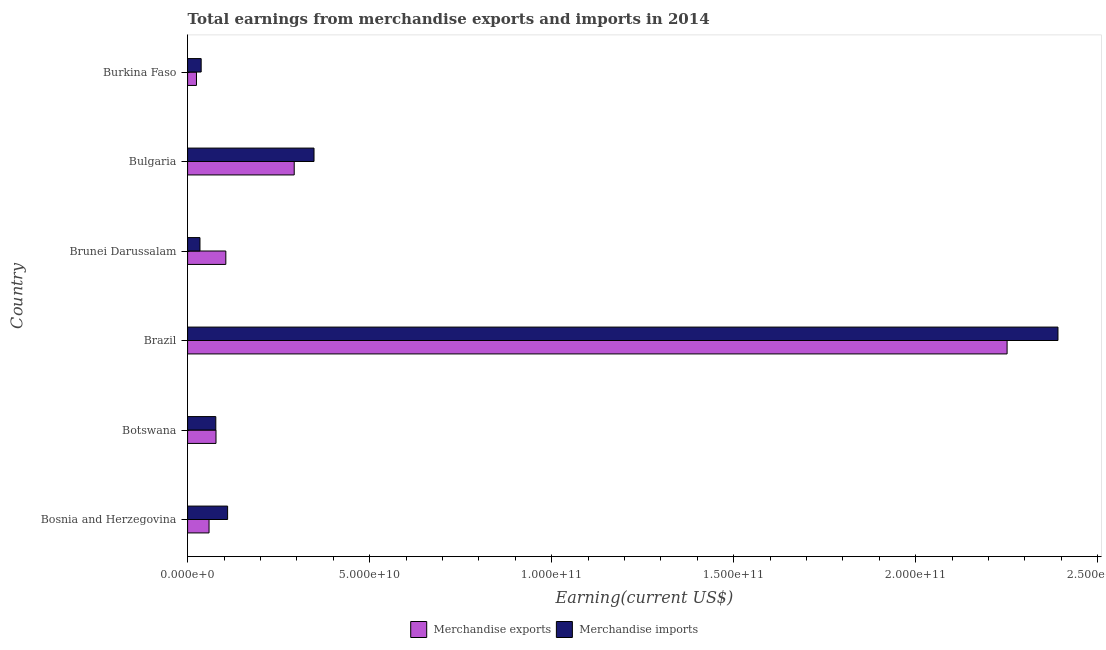Are the number of bars per tick equal to the number of legend labels?
Your answer should be very brief. Yes. How many bars are there on the 6th tick from the top?
Give a very brief answer. 2. How many bars are there on the 3rd tick from the bottom?
Provide a short and direct response. 2. What is the earnings from merchandise imports in Bosnia and Herzegovina?
Make the answer very short. 1.10e+1. Across all countries, what is the maximum earnings from merchandise exports?
Make the answer very short. 2.25e+11. Across all countries, what is the minimum earnings from merchandise imports?
Give a very brief answer. 3.40e+09. In which country was the earnings from merchandise imports maximum?
Keep it short and to the point. Brazil. In which country was the earnings from merchandise imports minimum?
Offer a terse response. Brunei Darussalam. What is the total earnings from merchandise imports in the graph?
Keep it short and to the point. 3.00e+11. What is the difference between the earnings from merchandise imports in Brazil and that in Burkina Faso?
Your response must be concise. 2.35e+11. What is the difference between the earnings from merchandise exports in Bulgaria and the earnings from merchandise imports in Bosnia and Herzegovina?
Keep it short and to the point. 1.83e+1. What is the average earnings from merchandise imports per country?
Your response must be concise. 4.99e+1. What is the difference between the earnings from merchandise imports and earnings from merchandise exports in Brunei Darussalam?
Offer a terse response. -7.10e+09. What is the ratio of the earnings from merchandise imports in Bosnia and Herzegovina to that in Burkina Faso?
Your answer should be very brief. 2.95. Is the earnings from merchandise exports in Brunei Darussalam less than that in Bulgaria?
Offer a terse response. Yes. What is the difference between the highest and the second highest earnings from merchandise exports?
Provide a succinct answer. 1.96e+11. What is the difference between the highest and the lowest earnings from merchandise exports?
Your answer should be very brief. 2.23e+11. Is the sum of the earnings from merchandise exports in Botswana and Burkina Faso greater than the maximum earnings from merchandise imports across all countries?
Ensure brevity in your answer.  No. What does the 1st bar from the bottom in Burkina Faso represents?
Give a very brief answer. Merchandise exports. How many bars are there?
Provide a succinct answer. 12. Are the values on the major ticks of X-axis written in scientific E-notation?
Offer a terse response. Yes. Does the graph contain any zero values?
Your answer should be very brief. No. Where does the legend appear in the graph?
Make the answer very short. Bottom center. How are the legend labels stacked?
Provide a short and direct response. Horizontal. What is the title of the graph?
Make the answer very short. Total earnings from merchandise exports and imports in 2014. What is the label or title of the X-axis?
Provide a short and direct response. Earning(current US$). What is the label or title of the Y-axis?
Your answer should be compact. Country. What is the Earning(current US$) of Merchandise exports in Bosnia and Herzegovina?
Offer a terse response. 5.89e+09. What is the Earning(current US$) in Merchandise imports in Bosnia and Herzegovina?
Make the answer very short. 1.10e+1. What is the Earning(current US$) in Merchandise exports in Botswana?
Offer a very short reply. 7.80e+09. What is the Earning(current US$) of Merchandise imports in Botswana?
Give a very brief answer. 7.75e+09. What is the Earning(current US$) in Merchandise exports in Brazil?
Keep it short and to the point. 2.25e+11. What is the Earning(current US$) of Merchandise imports in Brazil?
Offer a very short reply. 2.39e+11. What is the Earning(current US$) in Merchandise exports in Brunei Darussalam?
Give a very brief answer. 1.05e+1. What is the Earning(current US$) of Merchandise imports in Brunei Darussalam?
Offer a terse response. 3.40e+09. What is the Earning(current US$) in Merchandise exports in Bulgaria?
Give a very brief answer. 2.93e+1. What is the Earning(current US$) of Merchandise imports in Bulgaria?
Keep it short and to the point. 3.47e+1. What is the Earning(current US$) in Merchandise exports in Burkina Faso?
Offer a terse response. 2.44e+09. What is the Earning(current US$) in Merchandise imports in Burkina Faso?
Make the answer very short. 3.73e+09. Across all countries, what is the maximum Earning(current US$) in Merchandise exports?
Your answer should be very brief. 2.25e+11. Across all countries, what is the maximum Earning(current US$) in Merchandise imports?
Provide a succinct answer. 2.39e+11. Across all countries, what is the minimum Earning(current US$) of Merchandise exports?
Make the answer very short. 2.44e+09. Across all countries, what is the minimum Earning(current US$) of Merchandise imports?
Offer a very short reply. 3.40e+09. What is the total Earning(current US$) in Merchandise exports in the graph?
Offer a terse response. 2.81e+11. What is the total Earning(current US$) in Merchandise imports in the graph?
Your answer should be compact. 3.00e+11. What is the difference between the Earning(current US$) of Merchandise exports in Bosnia and Herzegovina and that in Botswana?
Your answer should be very brief. -1.91e+09. What is the difference between the Earning(current US$) in Merchandise imports in Bosnia and Herzegovina and that in Botswana?
Offer a very short reply. 3.24e+09. What is the difference between the Earning(current US$) of Merchandise exports in Bosnia and Herzegovina and that in Brazil?
Your response must be concise. -2.19e+11. What is the difference between the Earning(current US$) in Merchandise imports in Bosnia and Herzegovina and that in Brazil?
Your response must be concise. -2.28e+11. What is the difference between the Earning(current US$) of Merchandise exports in Bosnia and Herzegovina and that in Brunei Darussalam?
Your answer should be very brief. -4.61e+09. What is the difference between the Earning(current US$) of Merchandise imports in Bosnia and Herzegovina and that in Brunei Darussalam?
Offer a terse response. 7.59e+09. What is the difference between the Earning(current US$) of Merchandise exports in Bosnia and Herzegovina and that in Bulgaria?
Provide a short and direct response. -2.34e+1. What is the difference between the Earning(current US$) in Merchandise imports in Bosnia and Herzegovina and that in Bulgaria?
Provide a short and direct response. -2.37e+1. What is the difference between the Earning(current US$) in Merchandise exports in Bosnia and Herzegovina and that in Burkina Faso?
Ensure brevity in your answer.  3.46e+09. What is the difference between the Earning(current US$) of Merchandise imports in Bosnia and Herzegovina and that in Burkina Faso?
Keep it short and to the point. 7.26e+09. What is the difference between the Earning(current US$) of Merchandise exports in Botswana and that in Brazil?
Your response must be concise. -2.17e+11. What is the difference between the Earning(current US$) in Merchandise imports in Botswana and that in Brazil?
Your answer should be compact. -2.31e+11. What is the difference between the Earning(current US$) of Merchandise exports in Botswana and that in Brunei Darussalam?
Give a very brief answer. -2.70e+09. What is the difference between the Earning(current US$) in Merchandise imports in Botswana and that in Brunei Darussalam?
Offer a very short reply. 4.35e+09. What is the difference between the Earning(current US$) in Merchandise exports in Botswana and that in Bulgaria?
Your response must be concise. -2.15e+1. What is the difference between the Earning(current US$) in Merchandise imports in Botswana and that in Bulgaria?
Give a very brief answer. -2.70e+1. What is the difference between the Earning(current US$) in Merchandise exports in Botswana and that in Burkina Faso?
Make the answer very short. 5.36e+09. What is the difference between the Earning(current US$) in Merchandise imports in Botswana and that in Burkina Faso?
Provide a short and direct response. 4.02e+09. What is the difference between the Earning(current US$) of Merchandise exports in Brazil and that in Brunei Darussalam?
Your response must be concise. 2.15e+11. What is the difference between the Earning(current US$) of Merchandise imports in Brazil and that in Brunei Darussalam?
Provide a short and direct response. 2.36e+11. What is the difference between the Earning(current US$) in Merchandise exports in Brazil and that in Bulgaria?
Give a very brief answer. 1.96e+11. What is the difference between the Earning(current US$) of Merchandise imports in Brazil and that in Bulgaria?
Your response must be concise. 2.04e+11. What is the difference between the Earning(current US$) of Merchandise exports in Brazil and that in Burkina Faso?
Your response must be concise. 2.23e+11. What is the difference between the Earning(current US$) in Merchandise imports in Brazil and that in Burkina Faso?
Provide a succinct answer. 2.35e+11. What is the difference between the Earning(current US$) of Merchandise exports in Brunei Darussalam and that in Bulgaria?
Make the answer very short. -1.88e+1. What is the difference between the Earning(current US$) of Merchandise imports in Brunei Darussalam and that in Bulgaria?
Offer a very short reply. -3.13e+1. What is the difference between the Earning(current US$) in Merchandise exports in Brunei Darussalam and that in Burkina Faso?
Your response must be concise. 8.06e+09. What is the difference between the Earning(current US$) in Merchandise imports in Brunei Darussalam and that in Burkina Faso?
Offer a terse response. -3.30e+08. What is the difference between the Earning(current US$) of Merchandise exports in Bulgaria and that in Burkina Faso?
Your answer should be very brief. 2.69e+1. What is the difference between the Earning(current US$) in Merchandise imports in Bulgaria and that in Burkina Faso?
Your answer should be very brief. 3.10e+1. What is the difference between the Earning(current US$) of Merchandise exports in Bosnia and Herzegovina and the Earning(current US$) of Merchandise imports in Botswana?
Offer a very short reply. -1.86e+09. What is the difference between the Earning(current US$) in Merchandise exports in Bosnia and Herzegovina and the Earning(current US$) in Merchandise imports in Brazil?
Offer a very short reply. -2.33e+11. What is the difference between the Earning(current US$) of Merchandise exports in Bosnia and Herzegovina and the Earning(current US$) of Merchandise imports in Brunei Darussalam?
Keep it short and to the point. 2.49e+09. What is the difference between the Earning(current US$) in Merchandise exports in Bosnia and Herzegovina and the Earning(current US$) in Merchandise imports in Bulgaria?
Make the answer very short. -2.88e+1. What is the difference between the Earning(current US$) in Merchandise exports in Bosnia and Herzegovina and the Earning(current US$) in Merchandise imports in Burkina Faso?
Ensure brevity in your answer.  2.16e+09. What is the difference between the Earning(current US$) in Merchandise exports in Botswana and the Earning(current US$) in Merchandise imports in Brazil?
Make the answer very short. -2.31e+11. What is the difference between the Earning(current US$) in Merchandise exports in Botswana and the Earning(current US$) in Merchandise imports in Brunei Darussalam?
Make the answer very short. 4.40e+09. What is the difference between the Earning(current US$) in Merchandise exports in Botswana and the Earning(current US$) in Merchandise imports in Bulgaria?
Offer a terse response. -2.69e+1. What is the difference between the Earning(current US$) in Merchandise exports in Botswana and the Earning(current US$) in Merchandise imports in Burkina Faso?
Provide a succinct answer. 4.07e+09. What is the difference between the Earning(current US$) of Merchandise exports in Brazil and the Earning(current US$) of Merchandise imports in Brunei Darussalam?
Provide a short and direct response. 2.22e+11. What is the difference between the Earning(current US$) in Merchandise exports in Brazil and the Earning(current US$) in Merchandise imports in Bulgaria?
Provide a short and direct response. 1.90e+11. What is the difference between the Earning(current US$) of Merchandise exports in Brazil and the Earning(current US$) of Merchandise imports in Burkina Faso?
Your answer should be compact. 2.21e+11. What is the difference between the Earning(current US$) in Merchandise exports in Brunei Darussalam and the Earning(current US$) in Merchandise imports in Bulgaria?
Your answer should be compact. -2.42e+1. What is the difference between the Earning(current US$) of Merchandise exports in Brunei Darussalam and the Earning(current US$) of Merchandise imports in Burkina Faso?
Your answer should be compact. 6.77e+09. What is the difference between the Earning(current US$) in Merchandise exports in Bulgaria and the Earning(current US$) in Merchandise imports in Burkina Faso?
Your answer should be very brief. 2.56e+1. What is the average Earning(current US$) of Merchandise exports per country?
Provide a succinct answer. 4.68e+1. What is the average Earning(current US$) in Merchandise imports per country?
Make the answer very short. 4.99e+1. What is the difference between the Earning(current US$) of Merchandise exports and Earning(current US$) of Merchandise imports in Bosnia and Herzegovina?
Offer a terse response. -5.10e+09. What is the difference between the Earning(current US$) of Merchandise exports and Earning(current US$) of Merchandise imports in Botswana?
Keep it short and to the point. 5.00e+07. What is the difference between the Earning(current US$) of Merchandise exports and Earning(current US$) of Merchandise imports in Brazil?
Provide a short and direct response. -1.40e+1. What is the difference between the Earning(current US$) of Merchandise exports and Earning(current US$) of Merchandise imports in Brunei Darussalam?
Your answer should be very brief. 7.10e+09. What is the difference between the Earning(current US$) in Merchandise exports and Earning(current US$) in Merchandise imports in Bulgaria?
Your answer should be compact. -5.44e+09. What is the difference between the Earning(current US$) in Merchandise exports and Earning(current US$) in Merchandise imports in Burkina Faso?
Your answer should be compact. -1.29e+09. What is the ratio of the Earning(current US$) in Merchandise exports in Bosnia and Herzegovina to that in Botswana?
Give a very brief answer. 0.76. What is the ratio of the Earning(current US$) of Merchandise imports in Bosnia and Herzegovina to that in Botswana?
Give a very brief answer. 1.42. What is the ratio of the Earning(current US$) of Merchandise exports in Bosnia and Herzegovina to that in Brazil?
Keep it short and to the point. 0.03. What is the ratio of the Earning(current US$) in Merchandise imports in Bosnia and Herzegovina to that in Brazil?
Keep it short and to the point. 0.05. What is the ratio of the Earning(current US$) of Merchandise exports in Bosnia and Herzegovina to that in Brunei Darussalam?
Give a very brief answer. 0.56. What is the ratio of the Earning(current US$) of Merchandise imports in Bosnia and Herzegovina to that in Brunei Darussalam?
Offer a very short reply. 3.23. What is the ratio of the Earning(current US$) in Merchandise exports in Bosnia and Herzegovina to that in Bulgaria?
Your response must be concise. 0.2. What is the ratio of the Earning(current US$) in Merchandise imports in Bosnia and Herzegovina to that in Bulgaria?
Ensure brevity in your answer.  0.32. What is the ratio of the Earning(current US$) in Merchandise exports in Bosnia and Herzegovina to that in Burkina Faso?
Your answer should be compact. 2.42. What is the ratio of the Earning(current US$) of Merchandise imports in Bosnia and Herzegovina to that in Burkina Faso?
Make the answer very short. 2.95. What is the ratio of the Earning(current US$) of Merchandise exports in Botswana to that in Brazil?
Give a very brief answer. 0.03. What is the ratio of the Earning(current US$) in Merchandise imports in Botswana to that in Brazil?
Provide a succinct answer. 0.03. What is the ratio of the Earning(current US$) of Merchandise exports in Botswana to that in Brunei Darussalam?
Your answer should be very brief. 0.74. What is the ratio of the Earning(current US$) in Merchandise imports in Botswana to that in Brunei Darussalam?
Provide a short and direct response. 2.28. What is the ratio of the Earning(current US$) of Merchandise exports in Botswana to that in Bulgaria?
Keep it short and to the point. 0.27. What is the ratio of the Earning(current US$) in Merchandise imports in Botswana to that in Bulgaria?
Give a very brief answer. 0.22. What is the ratio of the Earning(current US$) of Merchandise exports in Botswana to that in Burkina Faso?
Ensure brevity in your answer.  3.2. What is the ratio of the Earning(current US$) in Merchandise imports in Botswana to that in Burkina Faso?
Your answer should be very brief. 2.08. What is the ratio of the Earning(current US$) in Merchandise exports in Brazil to that in Brunei Darussalam?
Ensure brevity in your answer.  21.44. What is the ratio of the Earning(current US$) of Merchandise imports in Brazil to that in Brunei Darussalam?
Offer a terse response. 70.32. What is the ratio of the Earning(current US$) of Merchandise exports in Brazil to that in Bulgaria?
Make the answer very short. 7.69. What is the ratio of the Earning(current US$) in Merchandise imports in Brazil to that in Bulgaria?
Ensure brevity in your answer.  6.88. What is the ratio of the Earning(current US$) in Merchandise exports in Brazil to that in Burkina Faso?
Your answer should be compact. 92.4. What is the ratio of the Earning(current US$) in Merchandise imports in Brazil to that in Burkina Faso?
Give a very brief answer. 64.1. What is the ratio of the Earning(current US$) in Merchandise exports in Brunei Darussalam to that in Bulgaria?
Give a very brief answer. 0.36. What is the ratio of the Earning(current US$) in Merchandise imports in Brunei Darussalam to that in Bulgaria?
Your answer should be very brief. 0.1. What is the ratio of the Earning(current US$) of Merchandise exports in Brunei Darussalam to that in Burkina Faso?
Provide a succinct answer. 4.31. What is the ratio of the Earning(current US$) in Merchandise imports in Brunei Darussalam to that in Burkina Faso?
Make the answer very short. 0.91. What is the ratio of the Earning(current US$) of Merchandise exports in Bulgaria to that in Burkina Faso?
Give a very brief answer. 12.02. What is the ratio of the Earning(current US$) in Merchandise imports in Bulgaria to that in Burkina Faso?
Offer a terse response. 9.31. What is the difference between the highest and the second highest Earning(current US$) in Merchandise exports?
Offer a very short reply. 1.96e+11. What is the difference between the highest and the second highest Earning(current US$) in Merchandise imports?
Offer a very short reply. 2.04e+11. What is the difference between the highest and the lowest Earning(current US$) of Merchandise exports?
Keep it short and to the point. 2.23e+11. What is the difference between the highest and the lowest Earning(current US$) of Merchandise imports?
Keep it short and to the point. 2.36e+11. 